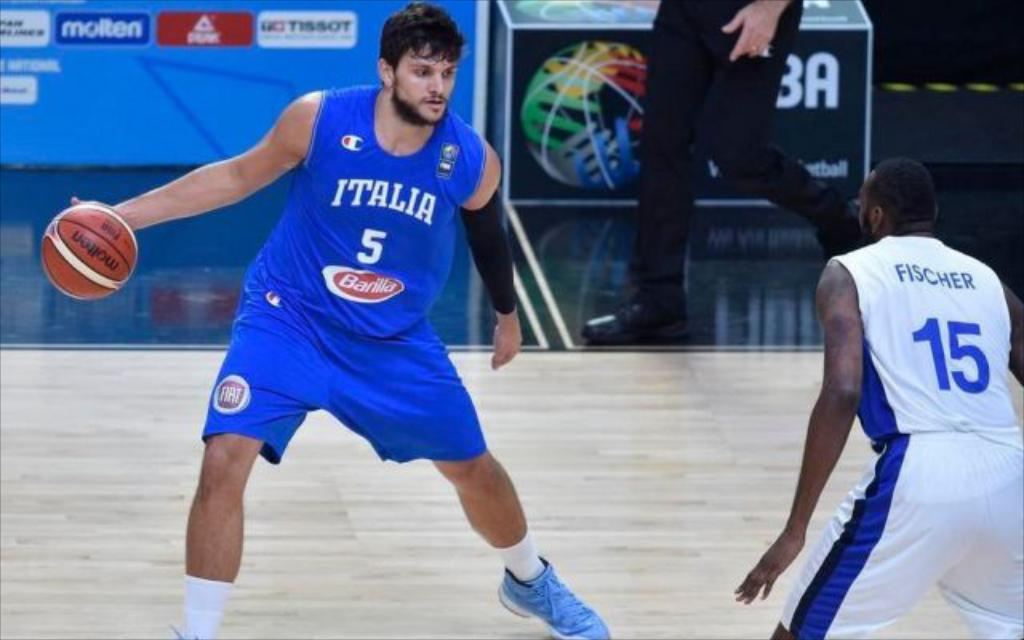<image>
Offer a succinct explanation of the picture presented. Number 5 is against number 15 on the baseball court. 